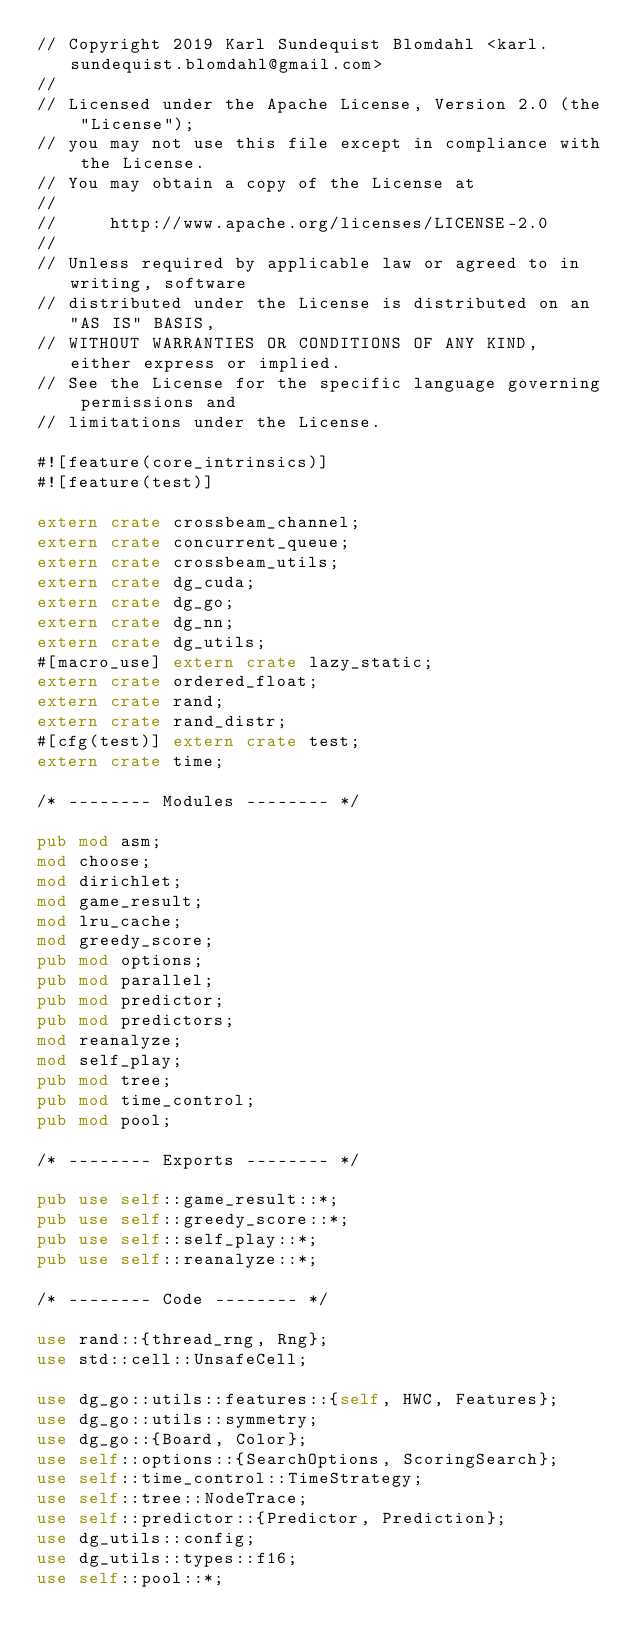<code> <loc_0><loc_0><loc_500><loc_500><_Rust_>// Copyright 2019 Karl Sundequist Blomdahl <karl.sundequist.blomdahl@gmail.com>
//
// Licensed under the Apache License, Version 2.0 (the "License");
// you may not use this file except in compliance with the License.
// You may obtain a copy of the License at
//
//     http://www.apache.org/licenses/LICENSE-2.0
//
// Unless required by applicable law or agreed to in writing, software
// distributed under the License is distributed on an "AS IS" BASIS,
// WITHOUT WARRANTIES OR CONDITIONS OF ANY KIND, either express or implied.
// See the License for the specific language governing permissions and
// limitations under the License.

#![feature(core_intrinsics)]
#![feature(test)]

extern crate crossbeam_channel;
extern crate concurrent_queue;
extern crate crossbeam_utils;
extern crate dg_cuda;
extern crate dg_go;
extern crate dg_nn;
extern crate dg_utils;
#[macro_use] extern crate lazy_static;
extern crate ordered_float;
extern crate rand;
extern crate rand_distr;
#[cfg(test)] extern crate test;
extern crate time;

/* -------- Modules -------- */

pub mod asm;
mod choose;
mod dirichlet;
mod game_result;
mod lru_cache;
mod greedy_score;
pub mod options;
pub mod parallel;
pub mod predictor;
pub mod predictors;
mod reanalyze;
mod self_play;
pub mod tree;
pub mod time_control;
pub mod pool;

/* -------- Exports -------- */

pub use self::game_result::*;
pub use self::greedy_score::*;
pub use self::self_play::*;
pub use self::reanalyze::*;

/* -------- Code -------- */

use rand::{thread_rng, Rng};
use std::cell::UnsafeCell;

use dg_go::utils::features::{self, HWC, Features};
use dg_go::utils::symmetry;
use dg_go::{Board, Color};
use self::options::{SearchOptions, ScoringSearch};
use self::time_control::TimeStrategy;
use self::tree::NodeTrace;
use self::predictor::{Predictor, Prediction};
use dg_utils::config;
use dg_utils::types::f16;
use self::pool::*;
</code> 